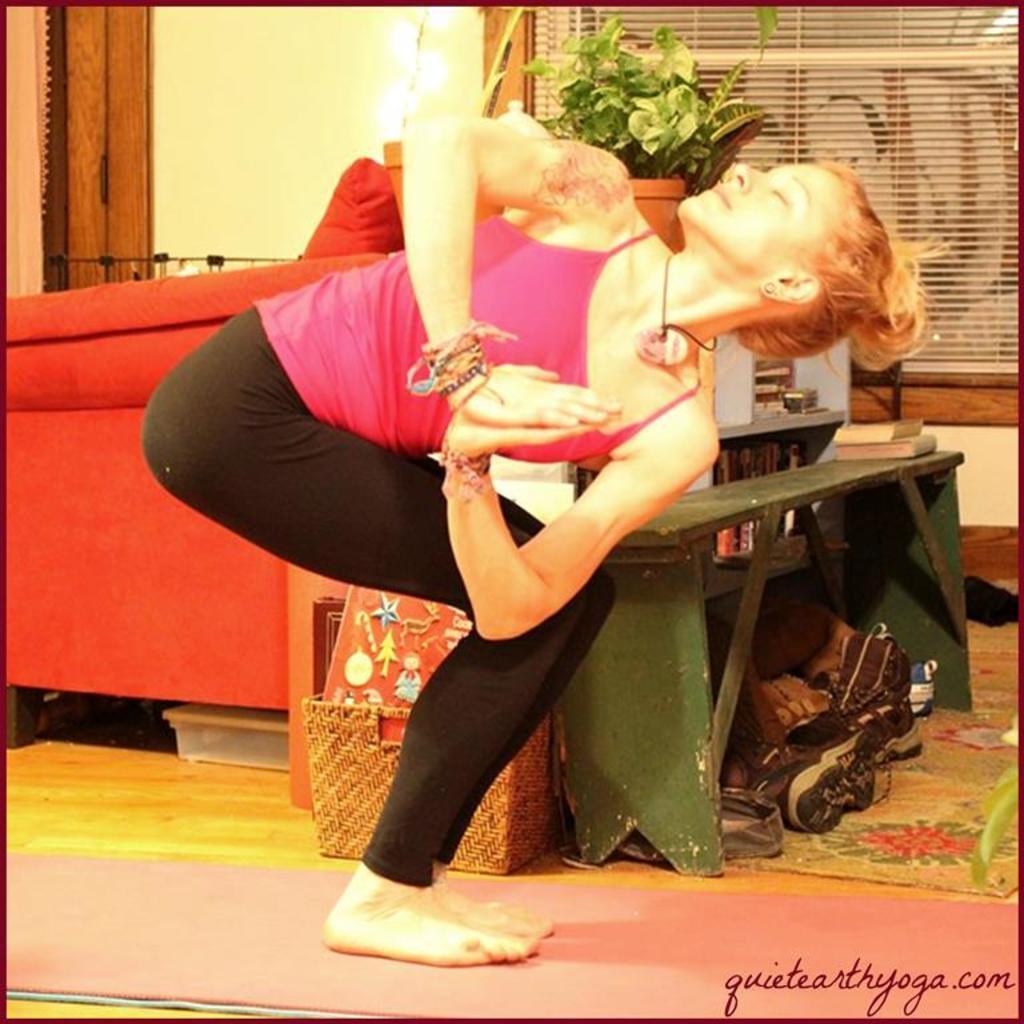In one or two sentences, can you explain what this image depicts? As we can see in the image there is a woman wearing pink color dress. There is a basket, book and a wall. 